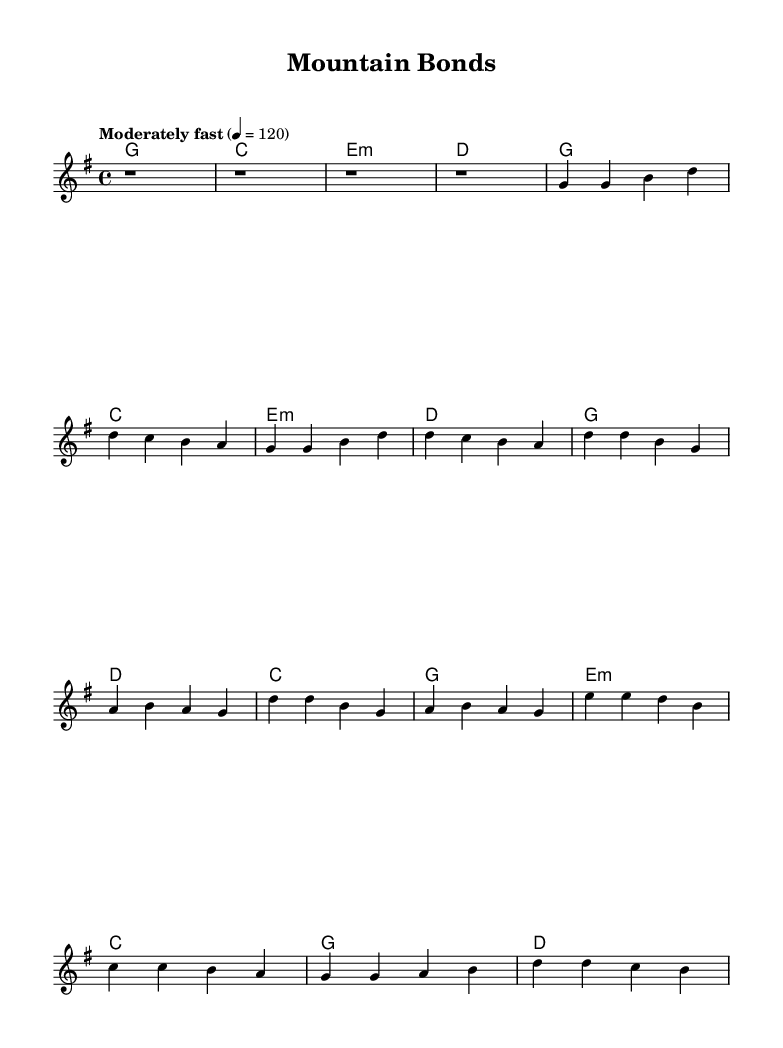What is the key signature of this music? The key signature shown in the music indicates the presence of one sharp, which indicates it is in the key of G major. G major has one sharp, which is F#.
Answer: G major What is the time signature of this piece? The time signature displayed at the beginning of the score is 4/4, which means there are four beats in each measure and a quarter note receives one beat.
Answer: 4/4 What is the tempo marking of this song? The tempo marking written in the score indicates "Moderately fast" with a speed of 120 beats per minute, which defines how fast the music should be played.
Answer: 120 How many measures are there in the chorus section? The chorus section consists of four lines of music, each containing four beats, totaling to 4 measures in that part of the song.
Answer: 4 What type of chords are used in the bridge section? The bridge section includes an e minor chord, a C major chord, a G major chord, and a D major chord, making the harmonic structure varied and engaging.
Answer: minor, major What musical genre does this piece fit into? The title and lyrical themes focus on mountain rescue teams and their bonds, which are common characteristics found in the country rock genre, blending elements of country and rock music.
Answer: Country Rock What is the structure of the song? The song has a common structure of an intro, followed by verses, a chorus, and a bridge, typical for country rock songs that explore storytelling elements.
Answer: Intro, Verse, Chorus, Bridge 